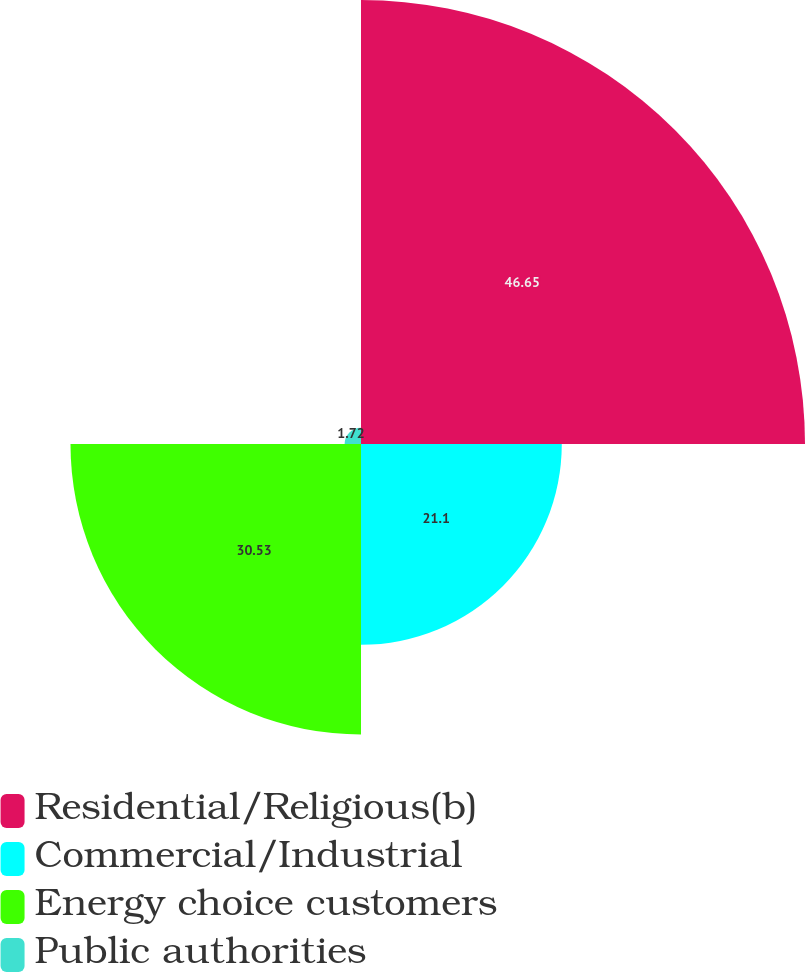Convert chart. <chart><loc_0><loc_0><loc_500><loc_500><pie_chart><fcel>Residential/Religious(b)<fcel>Commercial/Industrial<fcel>Energy choice customers<fcel>Public authorities<nl><fcel>46.66%<fcel>21.1%<fcel>30.53%<fcel>1.72%<nl></chart> 